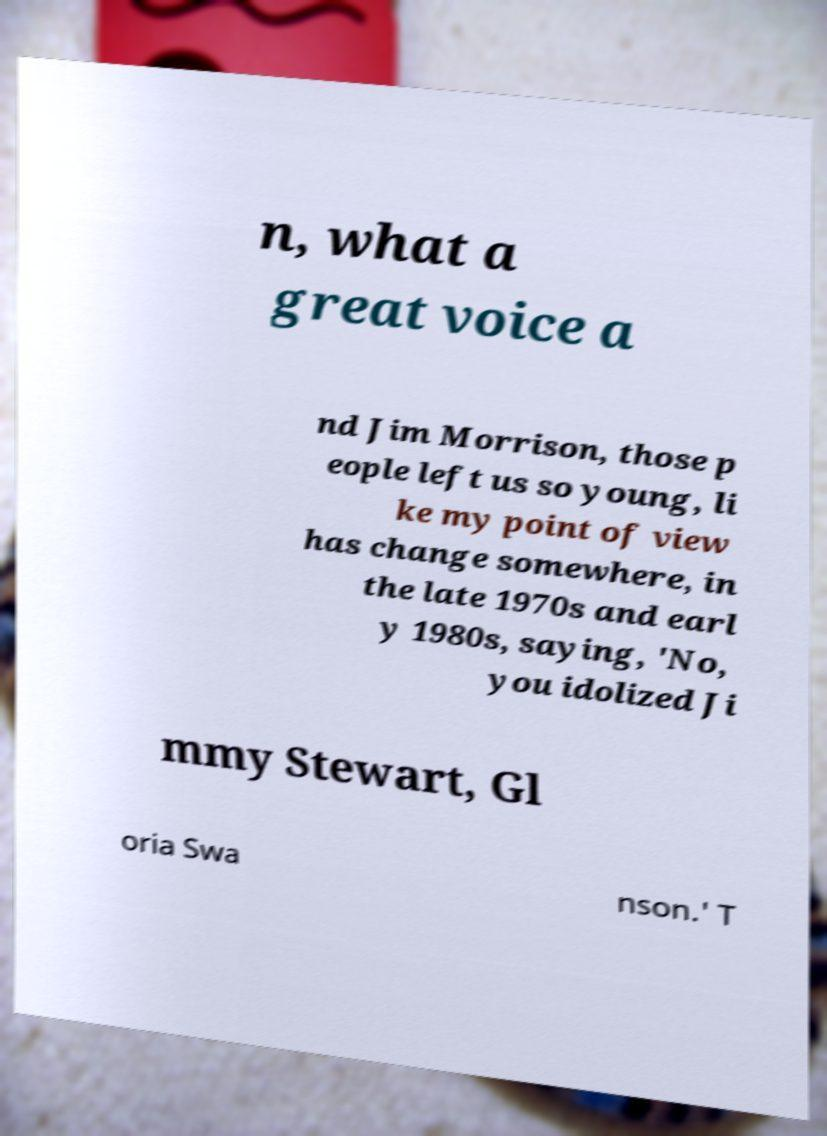Please read and relay the text visible in this image. What does it say? n, what a great voice a nd Jim Morrison, those p eople left us so young, li ke my point of view has change somewhere, in the late 1970s and earl y 1980s, saying, 'No, you idolized Ji mmy Stewart, Gl oria Swa nson.' T 